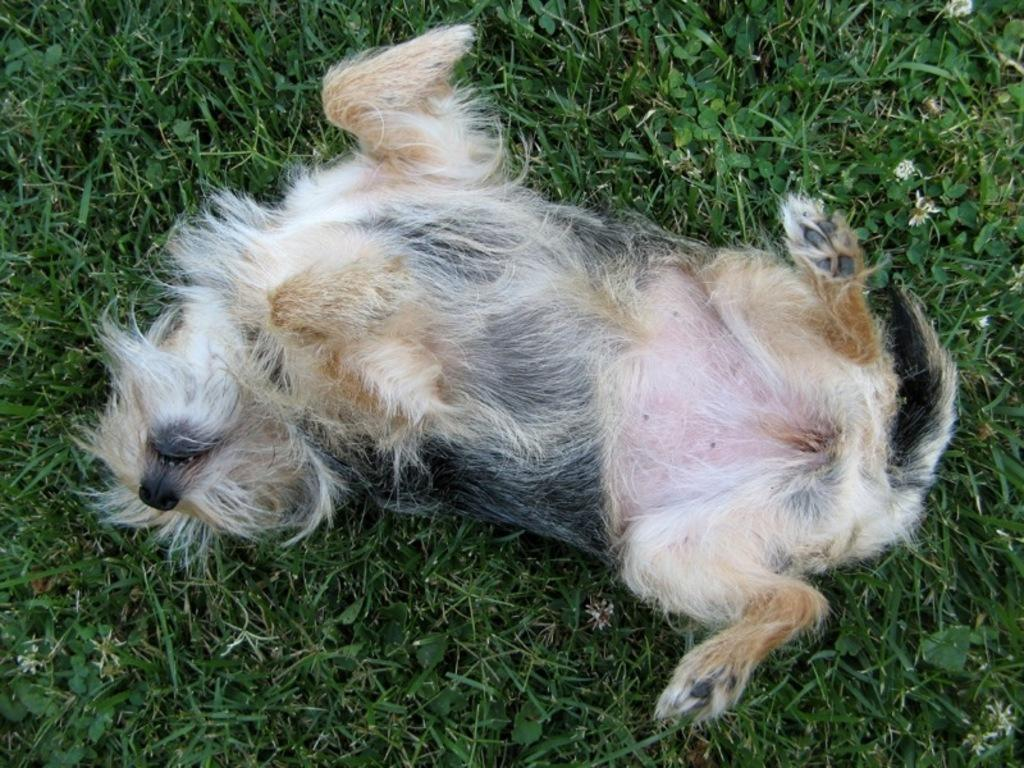What type of animal is in the image? There is a dog in the image. What color combination does the dog have? The dog has a white and black color combination. What position is the dog in? The dog is lying on the ground. What type of surface is the dog lying on? There is grass on the ground. What type of guitar is the dog playing in the image? There is no guitar present in the image; it features a dog lying on the grass. 